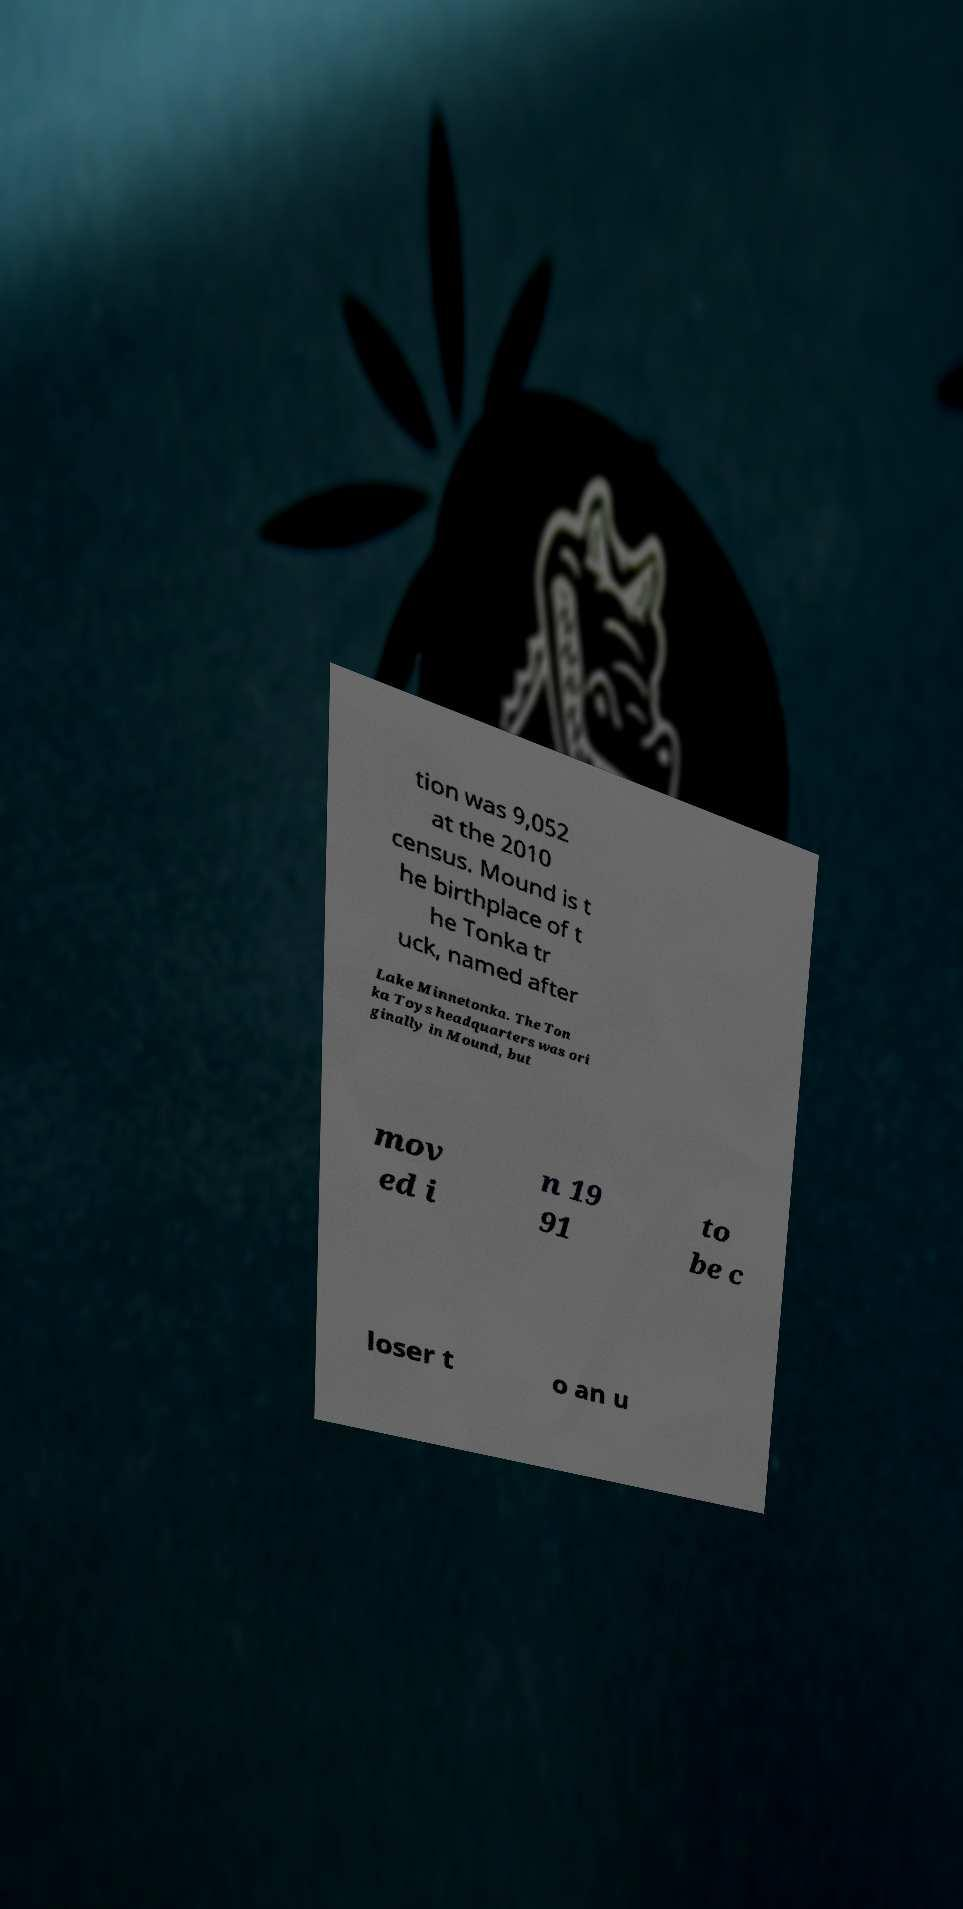What messages or text are displayed in this image? I need them in a readable, typed format. tion was 9,052 at the 2010 census. Mound is t he birthplace of t he Tonka tr uck, named after Lake Minnetonka. The Ton ka Toys headquarters was ori ginally in Mound, but mov ed i n 19 91 to be c loser t o an u 